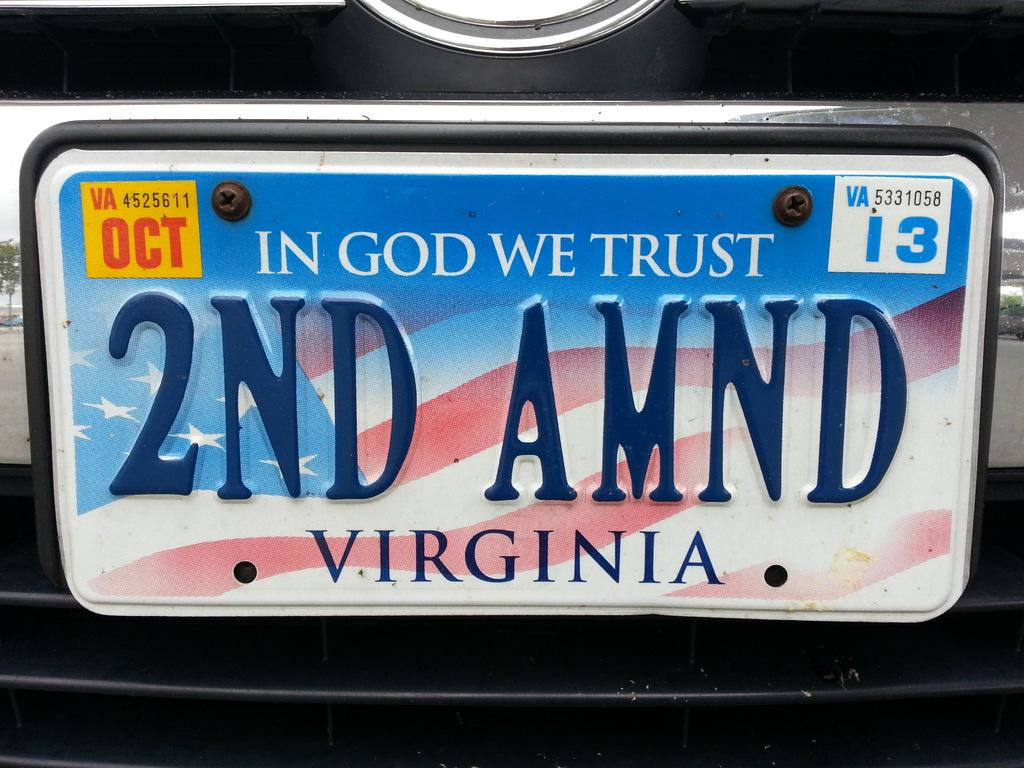<image>
Relay a brief, clear account of the picture shown. A Virginia license plate with "In God We Trust" at the top 